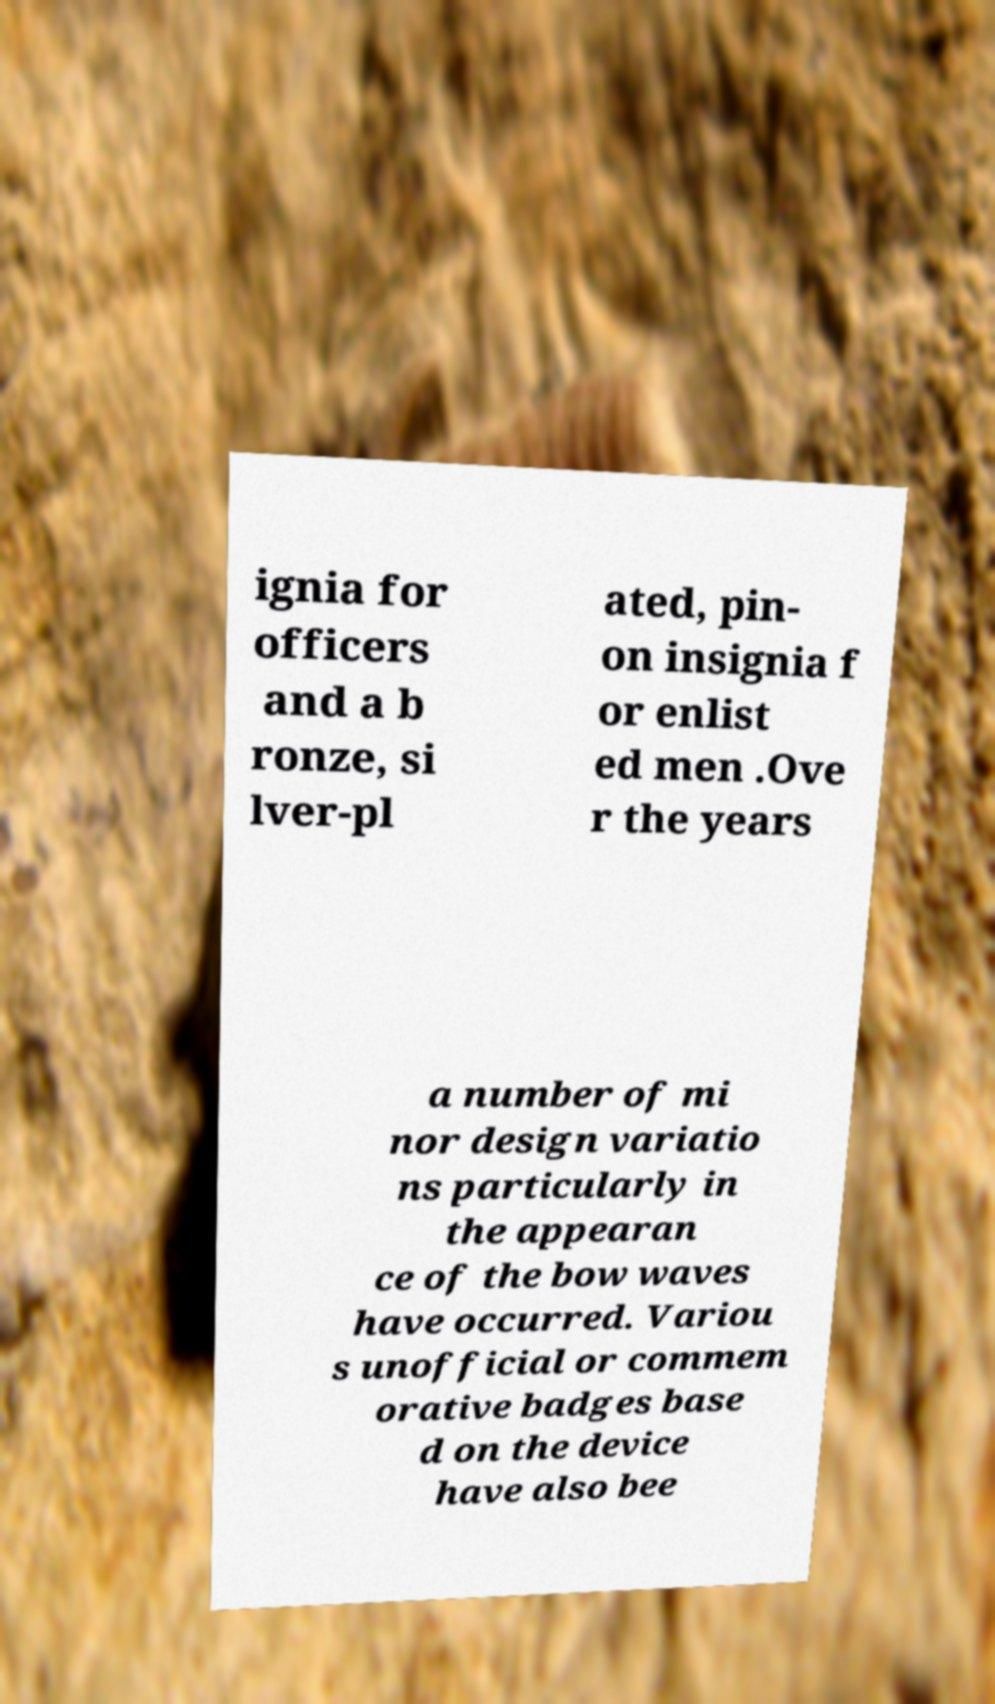Could you extract and type out the text from this image? ignia for officers and a b ronze, si lver-pl ated, pin- on insignia f or enlist ed men .Ove r the years a number of mi nor design variatio ns particularly in the appearan ce of the bow waves have occurred. Variou s unofficial or commem orative badges base d on the device have also bee 